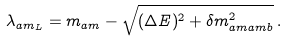<formula> <loc_0><loc_0><loc_500><loc_500>\lambda _ { \L a m _ { L } } = m _ { \L a m } - \sqrt { ( \Delta E ) ^ { 2 } + \delta m ^ { 2 } _ { \L a m \L a m b } } \, .</formula> 